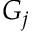Convert formula to latex. <formula><loc_0><loc_0><loc_500><loc_500>G _ { j }</formula> 